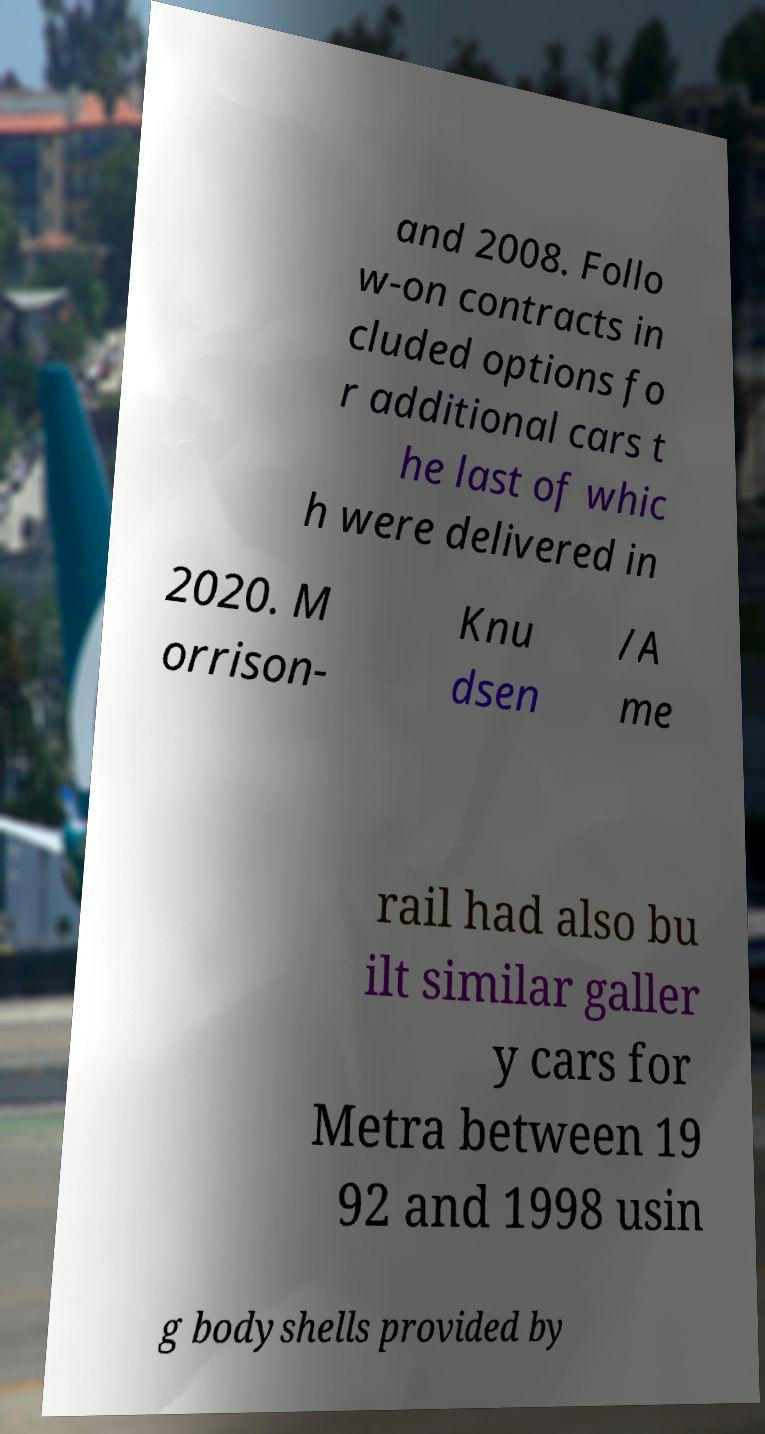There's text embedded in this image that I need extracted. Can you transcribe it verbatim? and 2008. Follo w-on contracts in cluded options fo r additional cars t he last of whic h were delivered in 2020. M orrison- Knu dsen /A me rail had also bu ilt similar galler y cars for Metra between 19 92 and 1998 usin g bodyshells provided by 